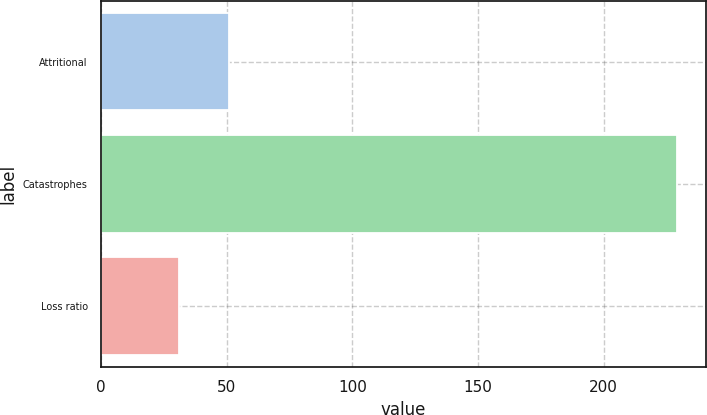Convert chart to OTSL. <chart><loc_0><loc_0><loc_500><loc_500><bar_chart><fcel>Attritional<fcel>Catastrophes<fcel>Loss ratio<nl><fcel>50.75<fcel>229.4<fcel>30.9<nl></chart> 